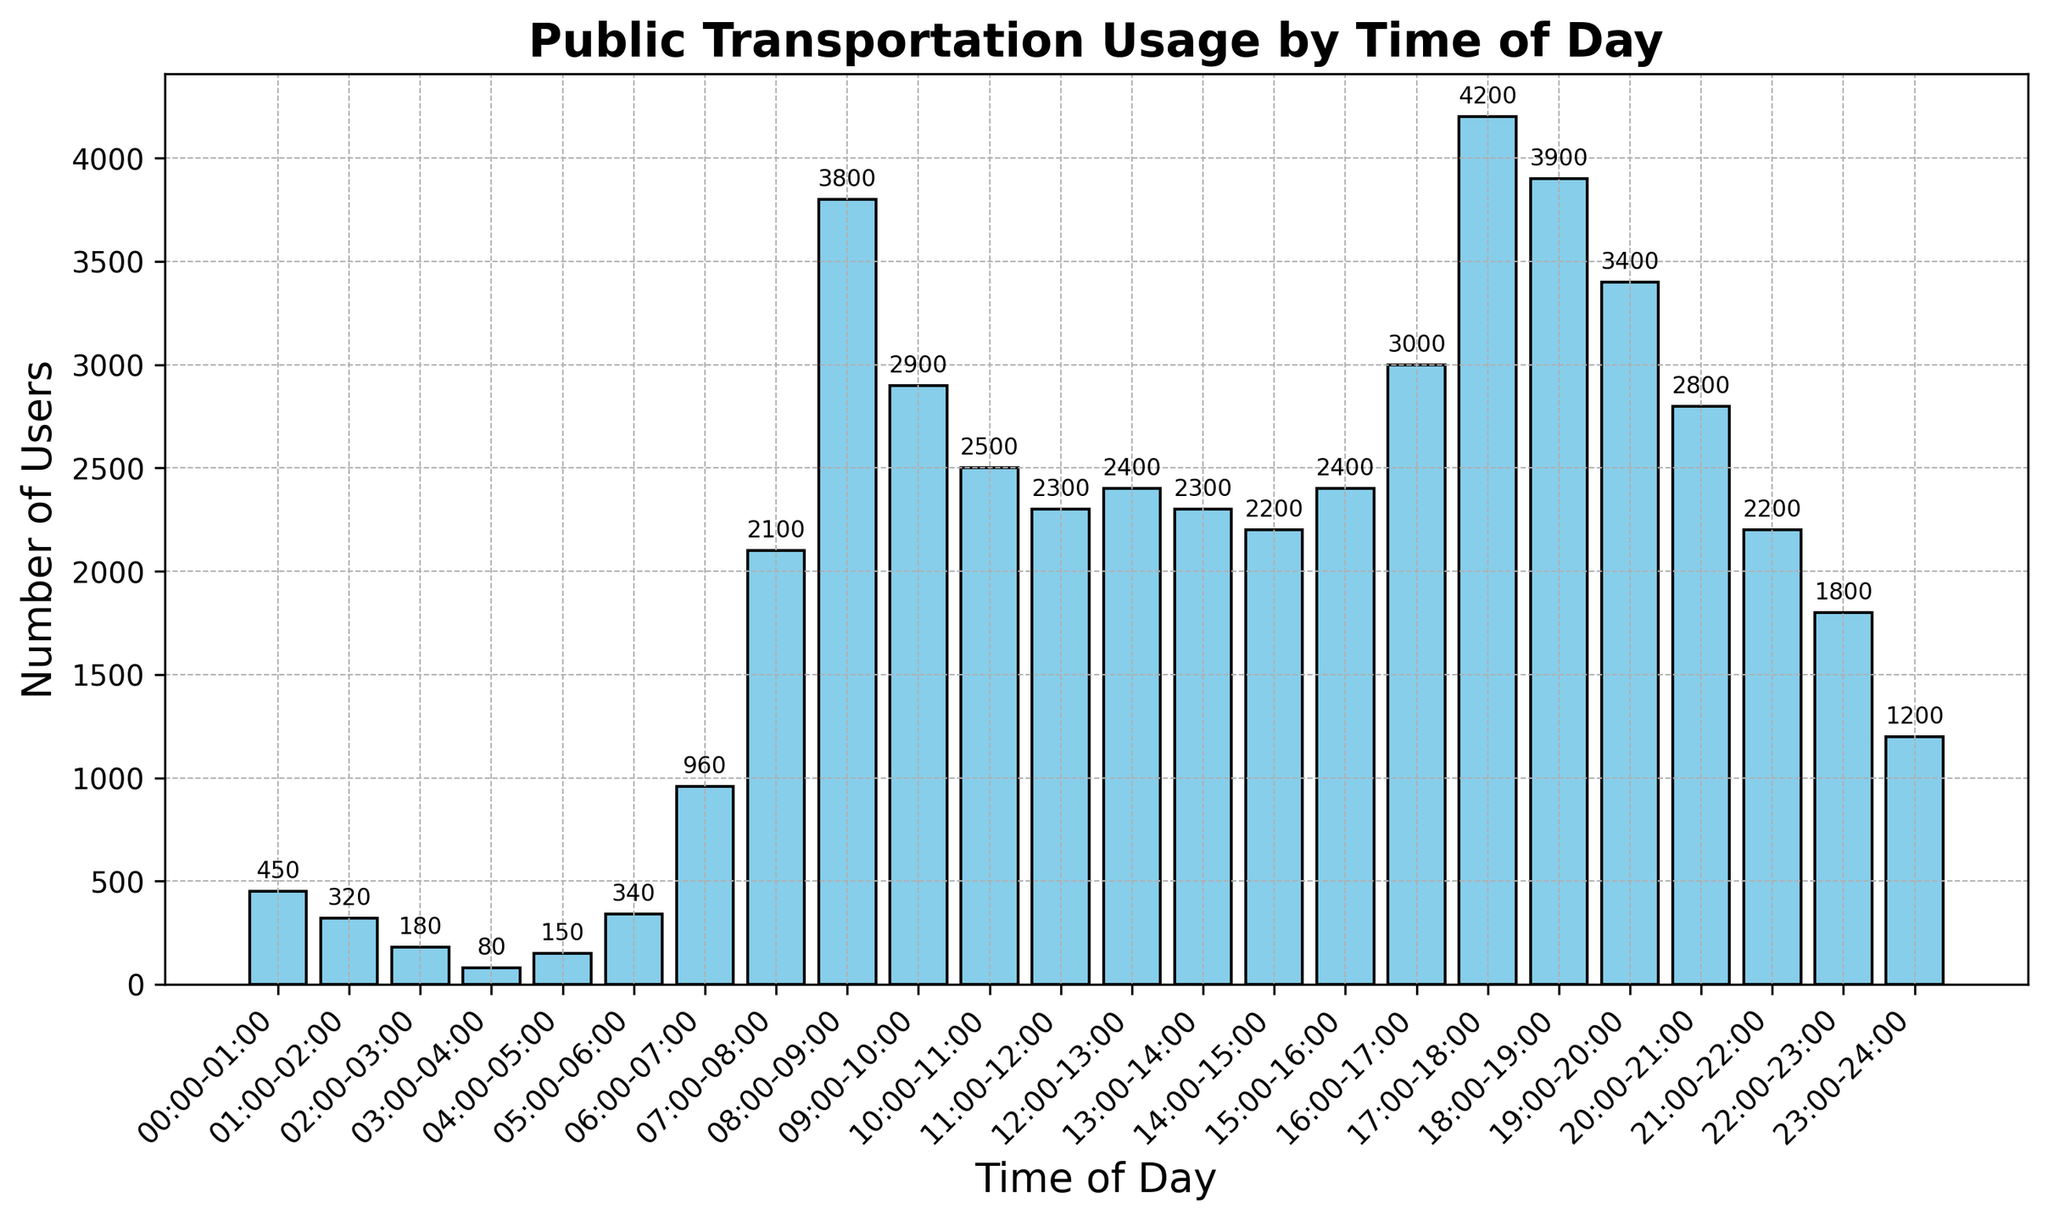What's the peak time for public transportation usage? Observing the heights of the bars in the histogram, the highest bar corresponds to the time range 17:00-18:00, indicating the peak usage time.
Answer: 17:00-18:00 Which time period has the least number of users? By comparing the heights of all bars, the shortest bar represents the time range 03:00-04:00, indicating the least number of users.
Answer: 03:00-04:00 How does the number of users change from 08:00-09:00 to 09:00-10:00? By looking at the heights of the bars, the number of users drops from 3800 during 08:00-09:00 to 2900 during 09:00-10:00. This is a decrease.
Answer: Decrease What is the average number of users from 16:00-18:00? Sum the number of users for the time ranges 16:00-17:00 and 17:00-18:00, then divide by the number of periods: (3000 + 4200) / 2 = 3600
Answer: 3600 Are there more users between 00:00-06:00 or 18:00-24:00? Sum the numbers for each time range. From 00:00-06:00: 450 + 320 + 180 + 80 + 150 + 340 = 1520. From 18:00-24:00: 3900 + 3400 + 2800 + 2200 + 1800 + 1200 = 15300.
Answer: 18:00-24:00 During which hour is the increase in the number of users the largest? Find the largest difference in the number of users between any two consecutive bars. The increase is largest between 07:00-08:00 and 08:00-09:00, with a difference of 3800 - 2100 = 1700.
Answer: 08:00-09:00 What is the difference in the number of users between the busiest and least busy times? Identify the highest and lowest bars. The busiest time is 17:00-18:00 with 4200 users, and the least busy time is 03:00-04:00 with 80 users. The difference is 4200 - 80 = 4120.
Answer: 4120 During which time periods is there a decline in the number of users? Find consecutive bars where the number of users decreases. Observing the graph, declines include: 08:00-09:00 to 09:00-10:00, 09:00-10:00 to 10:00-11:00, and 18:00-19:00 to 19:00-20:00.
Answer: 08:00-09:00 to 09:00-10:00, 09:00-10:00 to 10:00-11:00, 18:00-19:00 to 19:00-20:00 